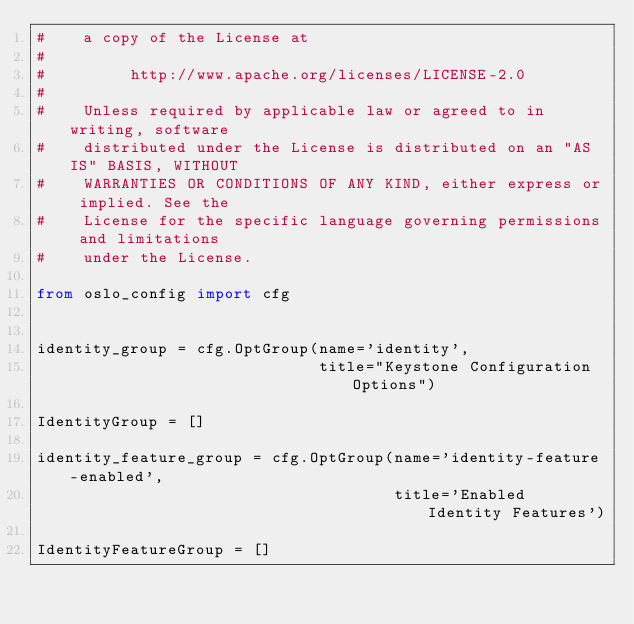Convert code to text. <code><loc_0><loc_0><loc_500><loc_500><_Python_>#    a copy of the License at
#
#         http://www.apache.org/licenses/LICENSE-2.0
#
#    Unless required by applicable law or agreed to in writing, software
#    distributed under the License is distributed on an "AS IS" BASIS, WITHOUT
#    WARRANTIES OR CONDITIONS OF ANY KIND, either express or implied. See the
#    License for the specific language governing permissions and limitations
#    under the License.

from oslo_config import cfg


identity_group = cfg.OptGroup(name='identity',
                              title="Keystone Configuration Options")

IdentityGroup = []

identity_feature_group = cfg.OptGroup(name='identity-feature-enabled',
                                      title='Enabled Identity Features')

IdentityFeatureGroup = []
</code> 